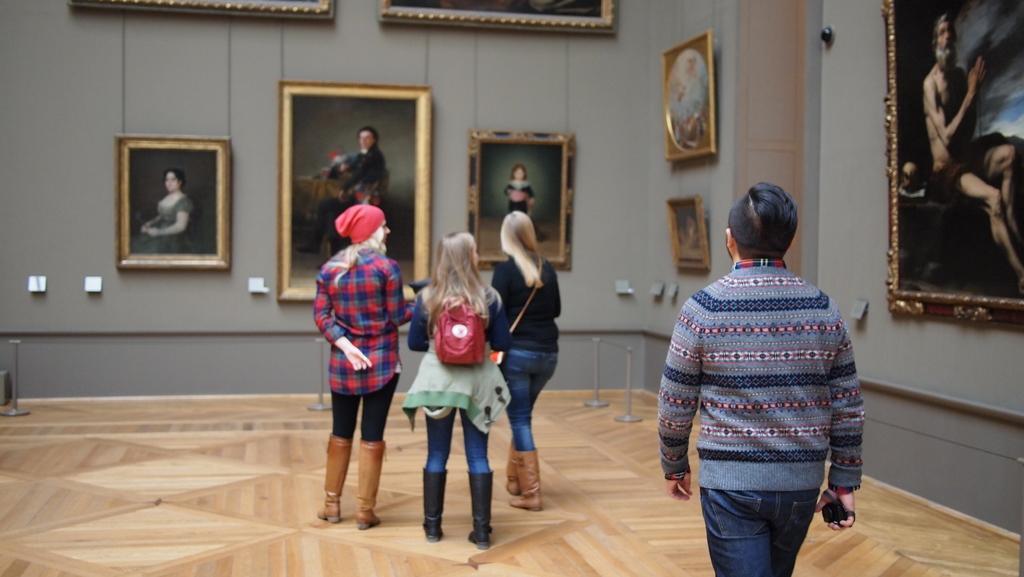Could you give a brief overview of what you see in this image? In this picture I can see 3 women and a man standing on the floor. In the background I can see the wall, on which there are number of photo frames of persons and I can see few silver color things. 